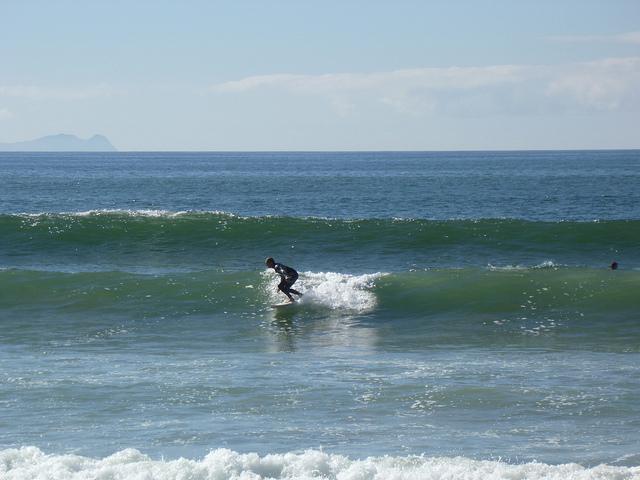Are the waves foamy?
Give a very brief answer. No. What color does the water look around the surfer?
Write a very short answer. Green. Is a wave hitting the people?
Short answer required. No. How many waves are breaking?
Quick response, please. 2. How many people are in the water?
Write a very short answer. 2. What is this person riding?
Be succinct. Surfboard. Why is only a small portion of the water appear white?
Write a very short answer. Waves. 